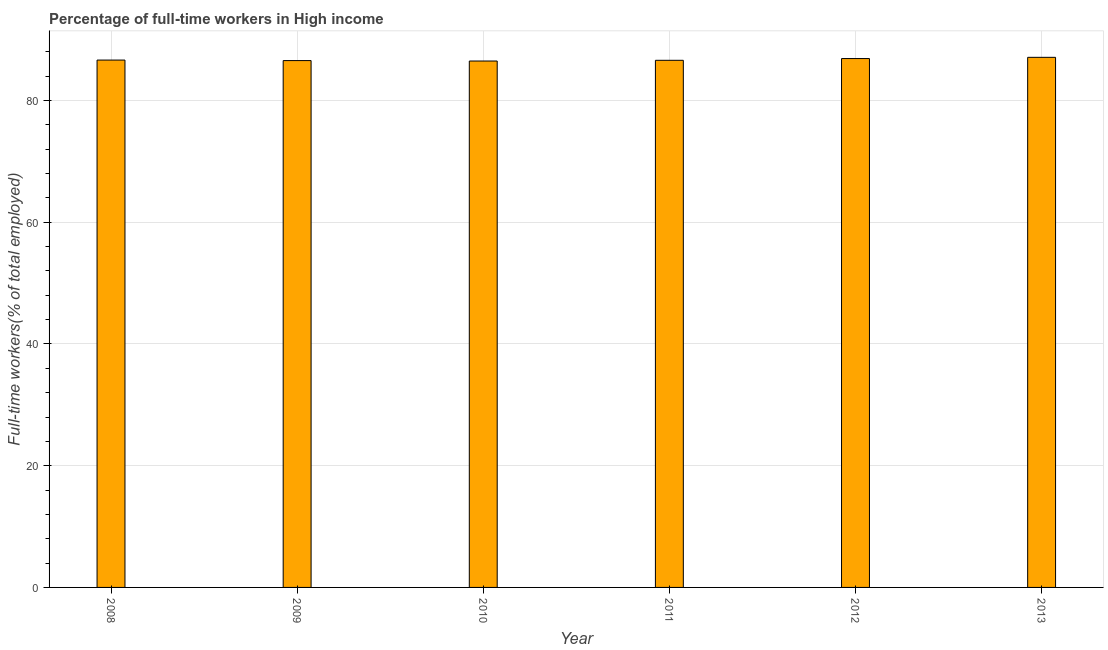Does the graph contain any zero values?
Provide a succinct answer. No. Does the graph contain grids?
Give a very brief answer. Yes. What is the title of the graph?
Ensure brevity in your answer.  Percentage of full-time workers in High income. What is the label or title of the X-axis?
Your answer should be very brief. Year. What is the label or title of the Y-axis?
Ensure brevity in your answer.  Full-time workers(% of total employed). What is the percentage of full-time workers in 2010?
Your answer should be compact. 86.49. Across all years, what is the maximum percentage of full-time workers?
Ensure brevity in your answer.  87.09. Across all years, what is the minimum percentage of full-time workers?
Your answer should be very brief. 86.49. In which year was the percentage of full-time workers maximum?
Ensure brevity in your answer.  2013. In which year was the percentage of full-time workers minimum?
Provide a short and direct response. 2010. What is the sum of the percentage of full-time workers?
Keep it short and to the point. 520.28. What is the difference between the percentage of full-time workers in 2010 and 2012?
Keep it short and to the point. -0.4. What is the average percentage of full-time workers per year?
Your answer should be compact. 86.71. What is the median percentage of full-time workers?
Your answer should be compact. 86.62. Do a majority of the years between 2011 and 2013 (inclusive) have percentage of full-time workers greater than 84 %?
Make the answer very short. Yes. What is the difference between the highest and the second highest percentage of full-time workers?
Give a very brief answer. 0.2. What is the difference between the highest and the lowest percentage of full-time workers?
Your response must be concise. 0.61. In how many years, is the percentage of full-time workers greater than the average percentage of full-time workers taken over all years?
Offer a very short reply. 2. How many years are there in the graph?
Ensure brevity in your answer.  6. Are the values on the major ticks of Y-axis written in scientific E-notation?
Your answer should be compact. No. What is the Full-time workers(% of total employed) of 2008?
Provide a succinct answer. 86.64. What is the Full-time workers(% of total employed) in 2009?
Your answer should be compact. 86.56. What is the Full-time workers(% of total employed) in 2010?
Keep it short and to the point. 86.49. What is the Full-time workers(% of total employed) in 2011?
Your response must be concise. 86.61. What is the Full-time workers(% of total employed) of 2012?
Provide a short and direct response. 86.89. What is the Full-time workers(% of total employed) of 2013?
Your response must be concise. 87.09. What is the difference between the Full-time workers(% of total employed) in 2008 and 2009?
Your answer should be very brief. 0.08. What is the difference between the Full-time workers(% of total employed) in 2008 and 2010?
Provide a succinct answer. 0.16. What is the difference between the Full-time workers(% of total employed) in 2008 and 2011?
Your response must be concise. 0.04. What is the difference between the Full-time workers(% of total employed) in 2008 and 2012?
Your answer should be compact. -0.25. What is the difference between the Full-time workers(% of total employed) in 2008 and 2013?
Offer a terse response. -0.45. What is the difference between the Full-time workers(% of total employed) in 2009 and 2010?
Make the answer very short. 0.07. What is the difference between the Full-time workers(% of total employed) in 2009 and 2011?
Make the answer very short. -0.05. What is the difference between the Full-time workers(% of total employed) in 2009 and 2012?
Provide a short and direct response. -0.33. What is the difference between the Full-time workers(% of total employed) in 2009 and 2013?
Make the answer very short. -0.53. What is the difference between the Full-time workers(% of total employed) in 2010 and 2011?
Your answer should be very brief. -0.12. What is the difference between the Full-time workers(% of total employed) in 2010 and 2012?
Your answer should be very brief. -0.4. What is the difference between the Full-time workers(% of total employed) in 2010 and 2013?
Provide a short and direct response. -0.61. What is the difference between the Full-time workers(% of total employed) in 2011 and 2012?
Offer a very short reply. -0.29. What is the difference between the Full-time workers(% of total employed) in 2011 and 2013?
Offer a terse response. -0.49. What is the difference between the Full-time workers(% of total employed) in 2012 and 2013?
Keep it short and to the point. -0.2. What is the ratio of the Full-time workers(% of total employed) in 2008 to that in 2012?
Ensure brevity in your answer.  1. What is the ratio of the Full-time workers(% of total employed) in 2009 to that in 2010?
Keep it short and to the point. 1. What is the ratio of the Full-time workers(% of total employed) in 2009 to that in 2011?
Offer a terse response. 1. What is the ratio of the Full-time workers(% of total employed) in 2010 to that in 2011?
Offer a very short reply. 1. What is the ratio of the Full-time workers(% of total employed) in 2010 to that in 2012?
Ensure brevity in your answer.  0.99. What is the ratio of the Full-time workers(% of total employed) in 2011 to that in 2013?
Your answer should be compact. 0.99. 